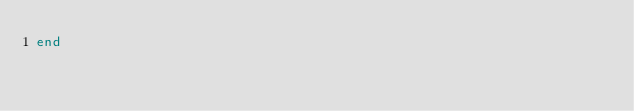<code> <loc_0><loc_0><loc_500><loc_500><_Ruby_>end
</code> 